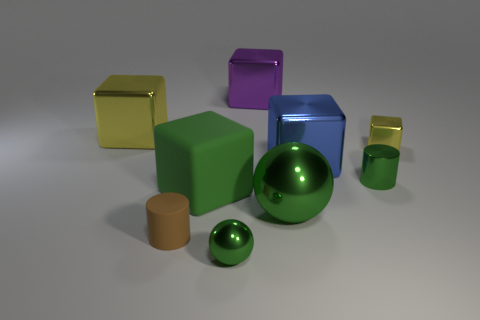Are there more shiny blocks than large purple shiny blocks?
Your answer should be very brief. Yes. The green shiny cylinder is what size?
Your answer should be compact. Small. What number of other objects are there of the same color as the small cube?
Offer a very short reply. 1. Do the small green object on the left side of the green shiny cylinder and the small green cylinder have the same material?
Offer a terse response. Yes. Are there fewer small matte objects that are in front of the green block than large balls behind the blue metal object?
Your answer should be very brief. No. What number of other things are there of the same material as the purple cube
Offer a terse response. 6. There is another brown cylinder that is the same size as the metallic cylinder; what is it made of?
Ensure brevity in your answer.  Rubber. Are there fewer tiny yellow things right of the tiny rubber object than small brown cubes?
Ensure brevity in your answer.  No. What shape is the big rubber object to the left of the big shiny object behind the yellow shiny object that is behind the small yellow cube?
Ensure brevity in your answer.  Cube. What is the size of the cube behind the large yellow shiny object?
Provide a short and direct response. Large. 